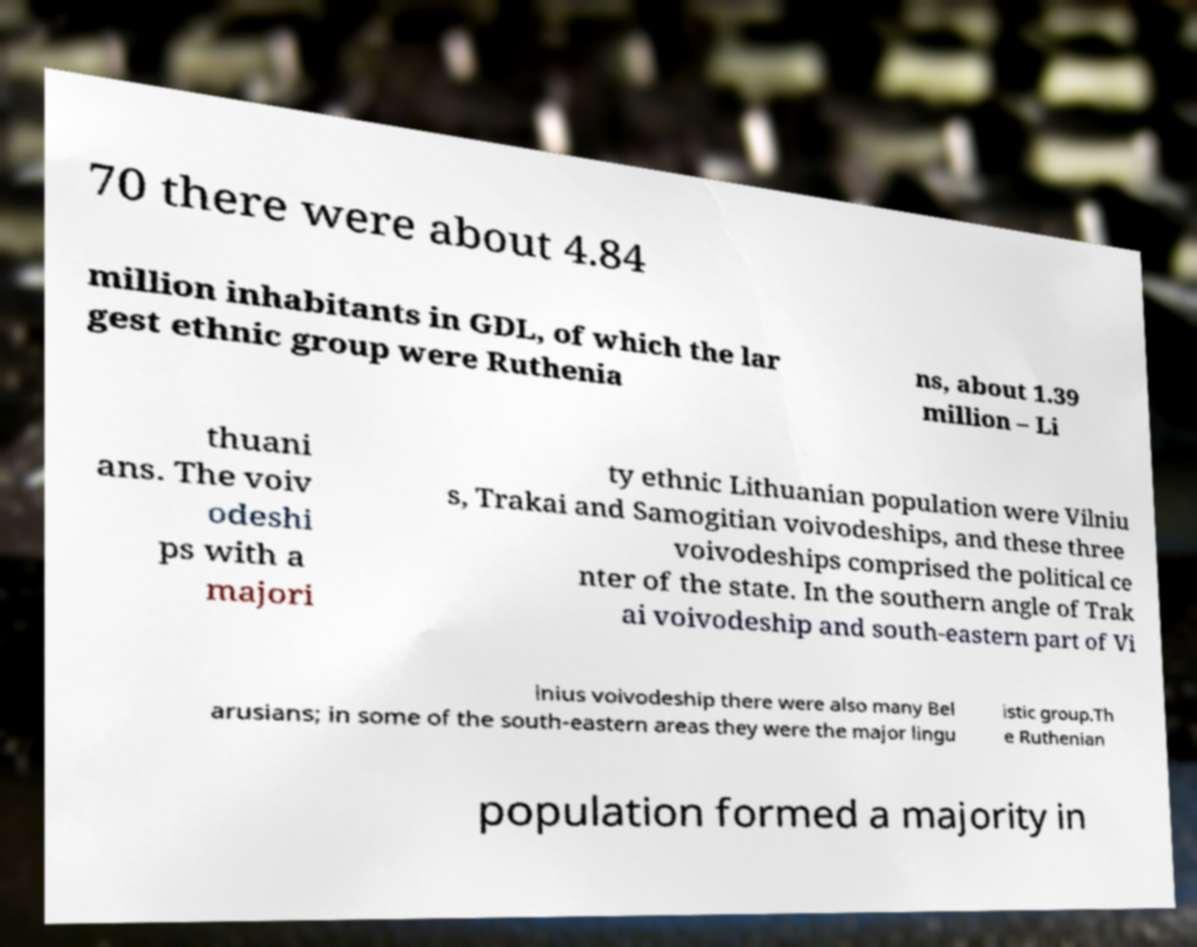What messages or text are displayed in this image? I need them in a readable, typed format. 70 there were about 4.84 million inhabitants in GDL, of which the lar gest ethnic group were Ruthenia ns, about 1.39 million – Li thuani ans. The voiv odeshi ps with a majori ty ethnic Lithuanian population were Vilniu s, Trakai and Samogitian voivodeships, and these three voivodeships comprised the political ce nter of the state. In the southern angle of Trak ai voivodeship and south-eastern part of Vi lnius voivodeship there were also many Bel arusians; in some of the south-eastern areas they were the major lingu istic group.Th e Ruthenian population formed a majority in 